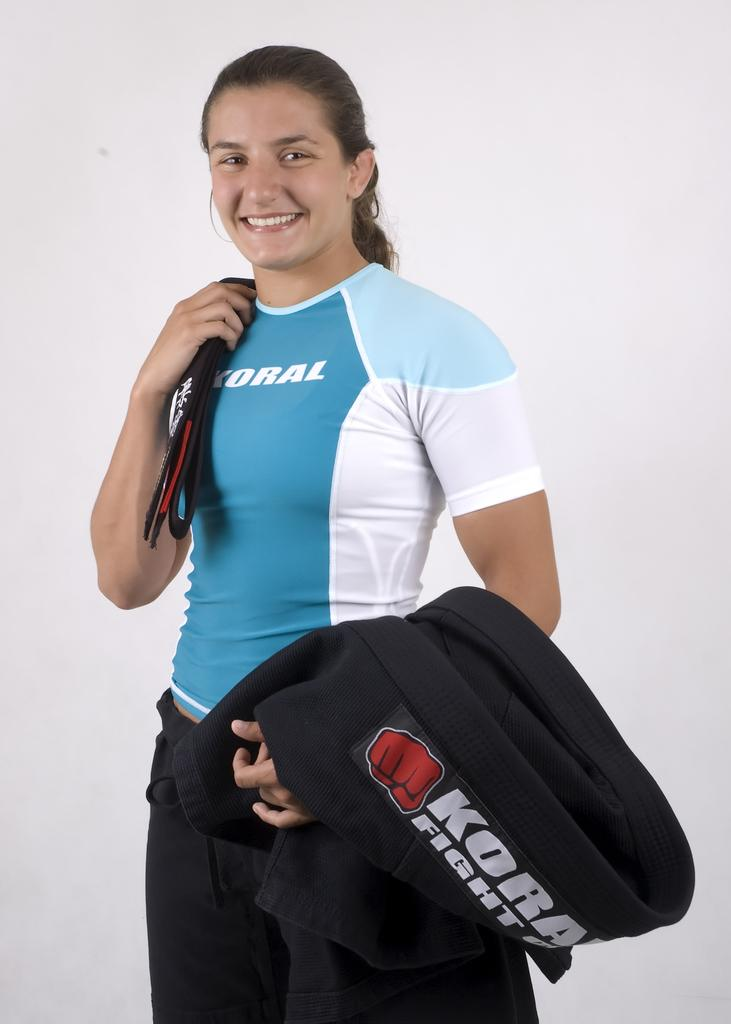Provide a one-sentence caption for the provided image. A fighter girl is posing for a Koral Fight gear photo. 